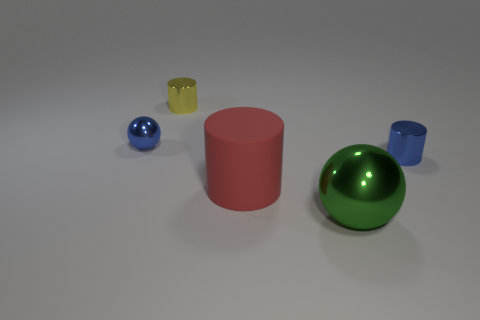Is there anything else that has the same material as the red cylinder?
Give a very brief answer. No. Do the cylinder right of the large cylinder and the large rubber cylinder have the same color?
Give a very brief answer. No. There is a cylinder behind the blue object that is left of the metal sphere that is in front of the large rubber cylinder; what is its material?
Make the answer very short. Metal. Do the red rubber cylinder and the green thing have the same size?
Keep it short and to the point. Yes. There is a big cylinder; is it the same color as the tiny cylinder right of the tiny yellow cylinder?
Provide a succinct answer. No. What shape is the blue object that is made of the same material as the blue cylinder?
Ensure brevity in your answer.  Sphere. There is a green object in front of the matte cylinder; is it the same shape as the rubber thing?
Offer a very short reply. No. How big is the metal thing to the left of the metallic cylinder behind the blue cylinder?
Give a very brief answer. Small. There is a tiny sphere that is made of the same material as the large green sphere; what color is it?
Your response must be concise. Blue. What number of green balls have the same size as the matte object?
Provide a succinct answer. 1. 